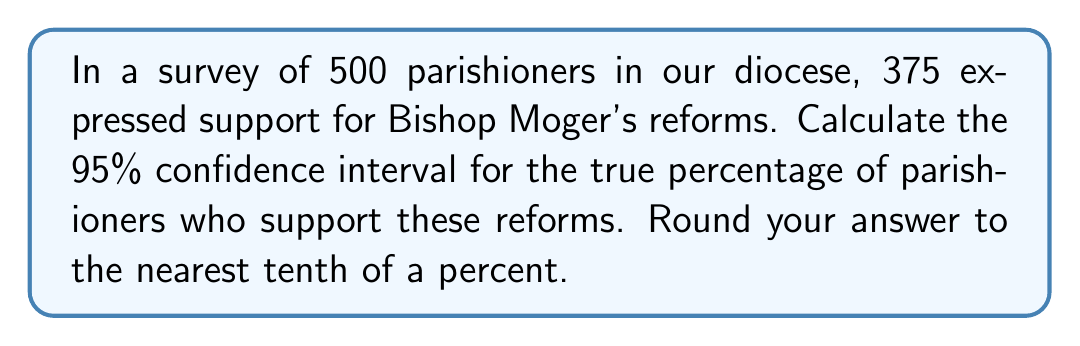Could you help me with this problem? To calculate the confidence interval, we'll use the formula:

$$ p \pm z \sqrt{\frac{p(1-p)}{n}} $$

Where:
$p$ = sample proportion
$z$ = z-score for 95% confidence level (1.96)
$n$ = sample size

Step 1: Calculate the sample proportion $(p)$
$p = \frac{375}{500} = 0.75$ or 75%

Step 2: Calculate the standard error
$SE = \sqrt{\frac{p(1-p)}{n}} = \sqrt{\frac{0.75(1-0.75)}{500}} = 0.0194$

Step 3: Calculate the margin of error
$ME = z \times SE = 1.96 \times 0.0194 = 0.0380$

Step 4: Calculate the confidence interval
Lower bound: $0.75 - 0.0380 = 0.7120$ or 71.2%
Upper bound: $0.75 + 0.0380 = 0.7880$ or 78.8%

Therefore, we can be 95% confident that the true percentage of parishioners who support Bishop Moger's reforms falls between 71.2% and 78.8%.
Answer: (71.2%, 78.8%) 